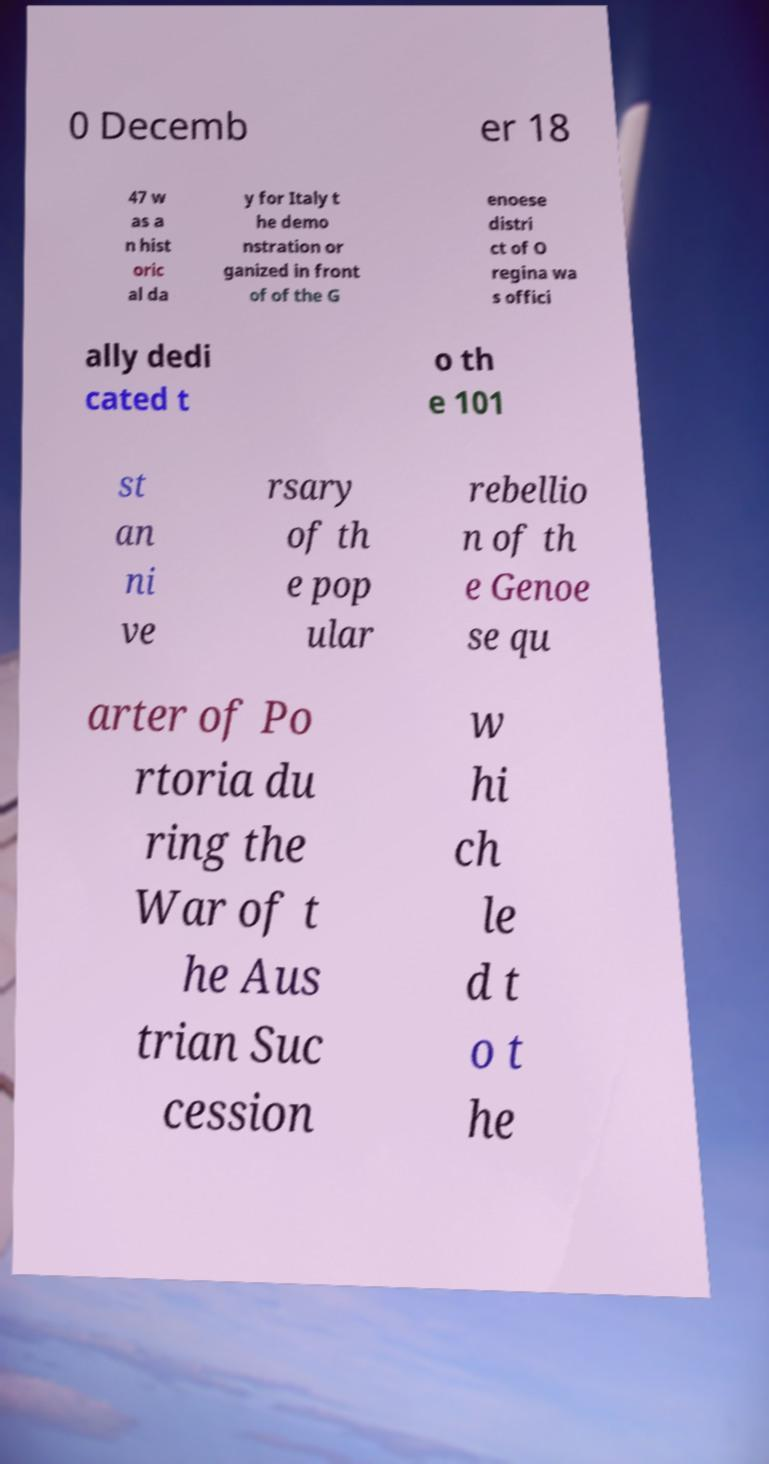There's text embedded in this image that I need extracted. Can you transcribe it verbatim? 0 Decemb er 18 47 w as a n hist oric al da y for Italy t he demo nstration or ganized in front of of the G enoese distri ct of O regina wa s offici ally dedi cated t o th e 101 st an ni ve rsary of th e pop ular rebellio n of th e Genoe se qu arter of Po rtoria du ring the War of t he Aus trian Suc cession w hi ch le d t o t he 